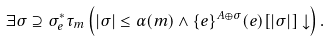<formula> <loc_0><loc_0><loc_500><loc_500>\exists \sigma \supseteq \sigma _ { e } ^ { * } \tau _ { m } \left ( | \sigma | \leq \alpha ( m ) \wedge \{ e \} ^ { A \oplus \sigma } ( e ) [ | \sigma | ] \downarrow \right ) .</formula> 